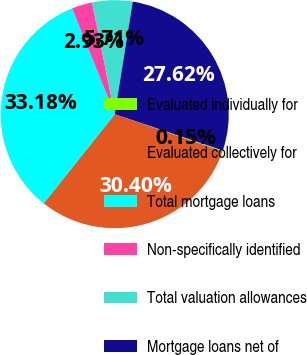<chart> <loc_0><loc_0><loc_500><loc_500><pie_chart><fcel>Evaluated individually for<fcel>Evaluated collectively for<fcel>Total mortgage loans<fcel>Non-specifically identified<fcel>Total valuation allowances<fcel>Mortgage loans net of<nl><fcel>0.15%<fcel>30.4%<fcel>33.18%<fcel>2.93%<fcel>5.71%<fcel>27.62%<nl></chart> 